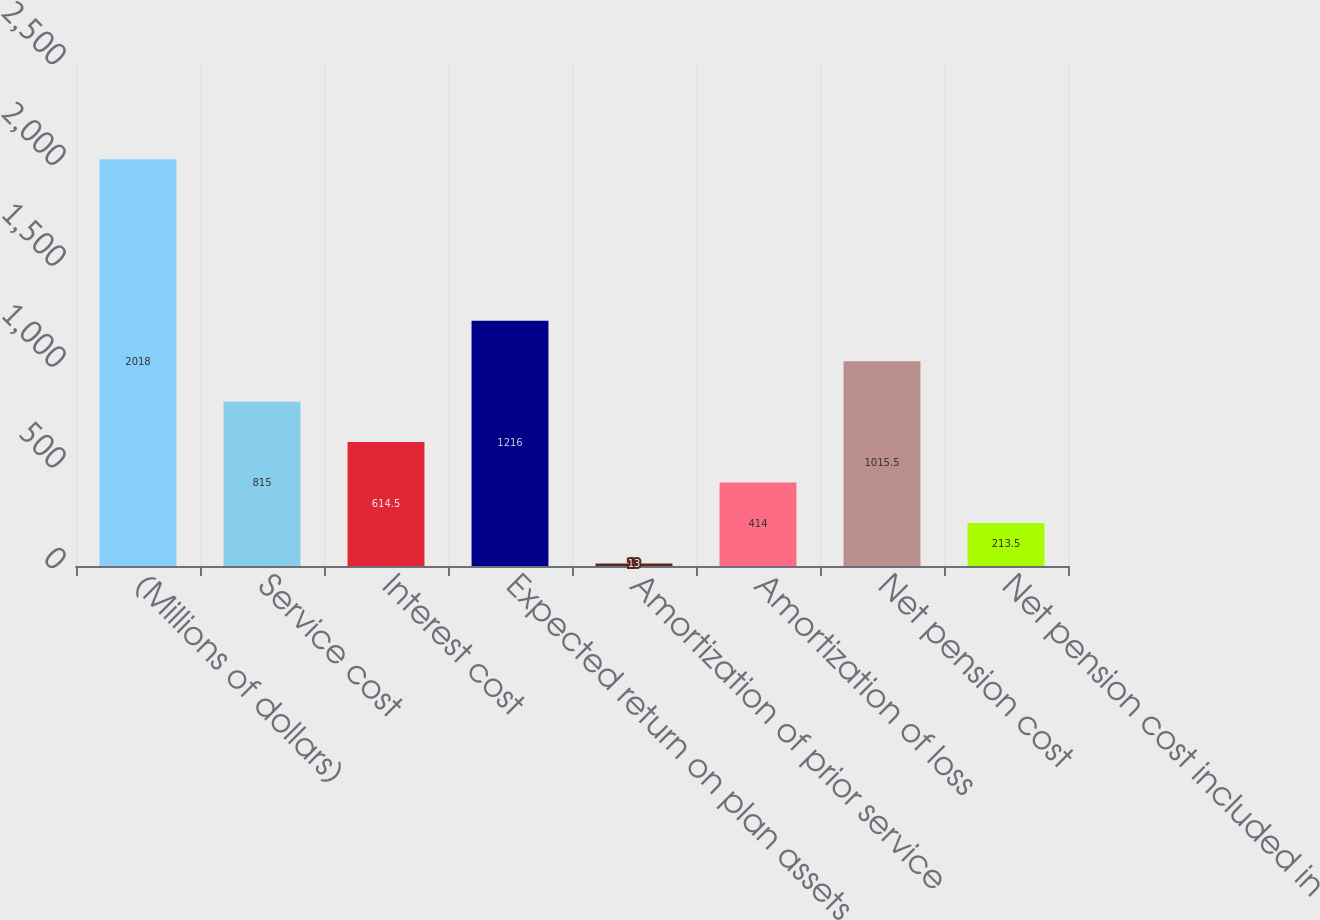Convert chart to OTSL. <chart><loc_0><loc_0><loc_500><loc_500><bar_chart><fcel>(Millions of dollars)<fcel>Service cost<fcel>Interest cost<fcel>Expected return on plan assets<fcel>Amortization of prior service<fcel>Amortization of loss<fcel>Net pension cost<fcel>Net pension cost included in<nl><fcel>2018<fcel>815<fcel>614.5<fcel>1216<fcel>13<fcel>414<fcel>1015.5<fcel>213.5<nl></chart> 